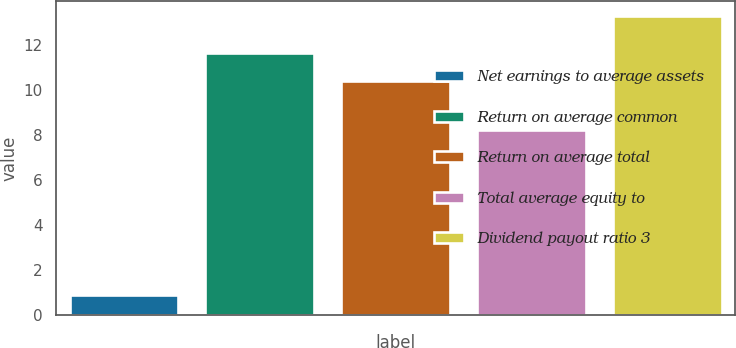<chart> <loc_0><loc_0><loc_500><loc_500><bar_chart><fcel>Net earnings to average assets<fcel>Return on average common<fcel>Return on average total<fcel>Total average equity to<fcel>Dividend payout ratio 3<nl><fcel>0.9<fcel>11.64<fcel>10.4<fcel>8.2<fcel>13.3<nl></chart> 